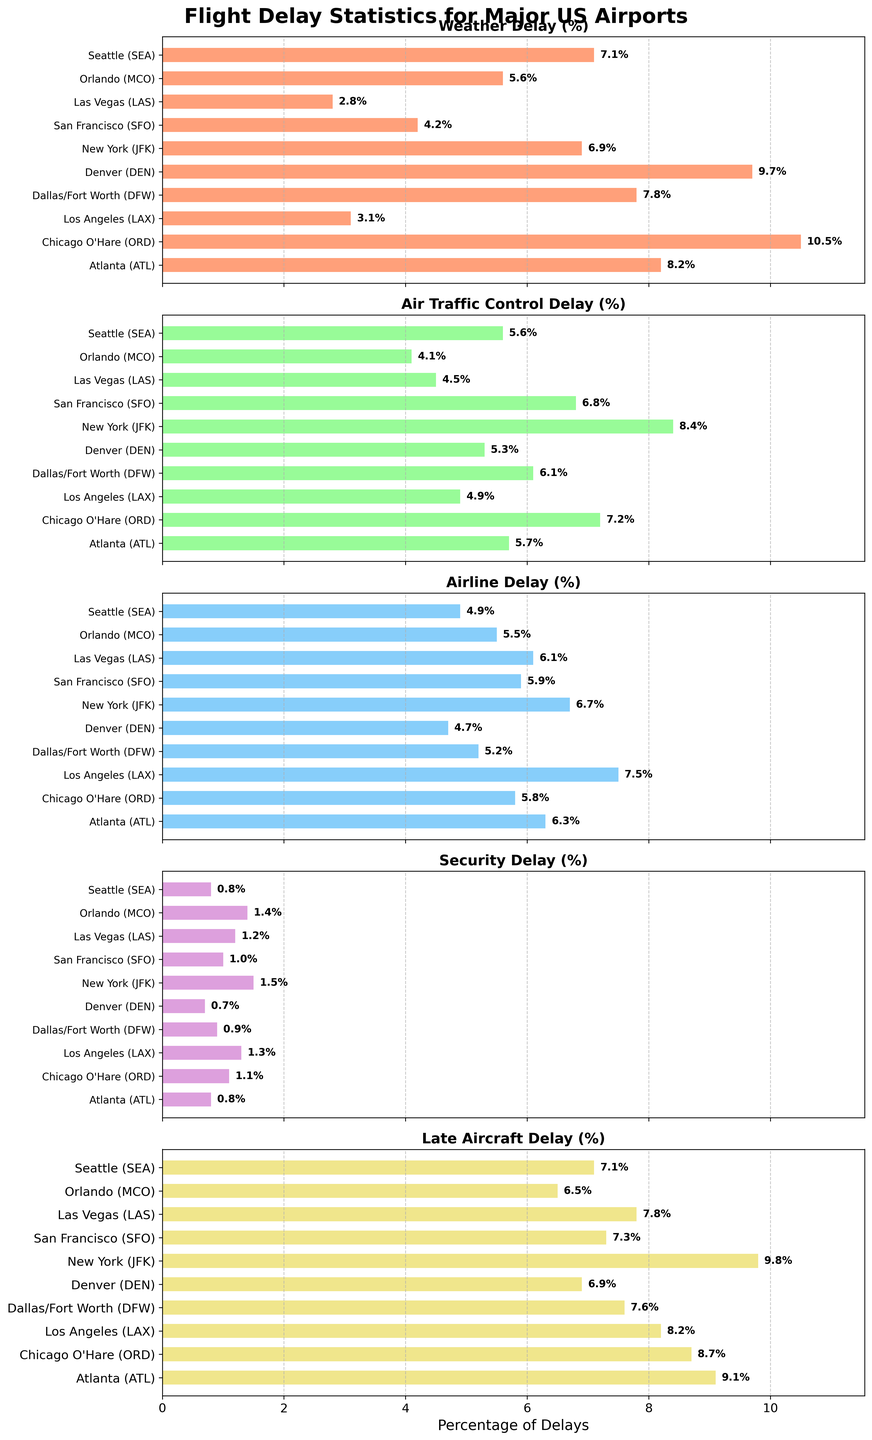Which airport has the highest percentage of weather delays? By looking at the horizontal bars in the "Weather Delay (%)" plot, you can see that Chicago O'Hare (ORD) has the longest bar, representing 10.5%.
Answer: Chicago O'Hare (ORD) What is the combined percentage of security delays at New York (JFK) and Los Angeles (LAX)? The security delay percentages for JFK and LAX are 1.5% and 1.3% respectively. Adding these two up gives 1.5 + 1.3 = 2.8%.
Answer: 2.8% Which airport has the lowest percentage of airline delays? By examining the horizontal bars in the "Airline Delay (%)" plot, Denver (DEN) has the shortest bar with a value of 4.7%.
Answer: Denver (DEN) Is the percentage of late aircraft delays higher at San Francisco (SFO) or Orlando (MCO)? Comparing the horizontal bars in the "Late Aircraft Delay (%)" plot, SFO has 7.3% while MCO has 6.5%. Therefore, SFO has a higher percentage.
Answer: San Francisco (SFO) What is the total percentage of air traffic control delays across all the airports? Summing up the air traffic control delay percentages for all airports: 5.7 + 7.2 + 4.9 + 6.1 + 5.3 + 8.4 + 6.8 + 4.5 + 4.1 + 5.6 = 58.6%.
Answer: 58.6% For Denver airport, how many delay causes are above 5%? Examine the values for Denver (DEN): Weather Delay (9.7%), Air Traffic Control (5.3%), Airline (4.7%), Security (0.7%), Late Aircraft (6.9%). Three causes are above 5%: Weather Delay, Air Traffic Control, and Late Aircraft.
Answer: 3 What’s the difference between the highest and lowest percentage of weather delays in the dataset? The highest weather delay percentage is at Chicago O'Hare (ORD) with 10.5%, and the lowest is at Las Vegas (LAS) with 2.8%. The difference is 10.5 - 2.8 = 7.7%.
Answer: 7.7% How do the percentages of air traffic control delays compare between New York (JFK) and Denver (DEN)? New York (JFK) has 8.4% and Denver (DEN) has 5.3% for air traffic control delays. 8.4% is higher than 5.3%.
Answer: New York (JFK) has higher 